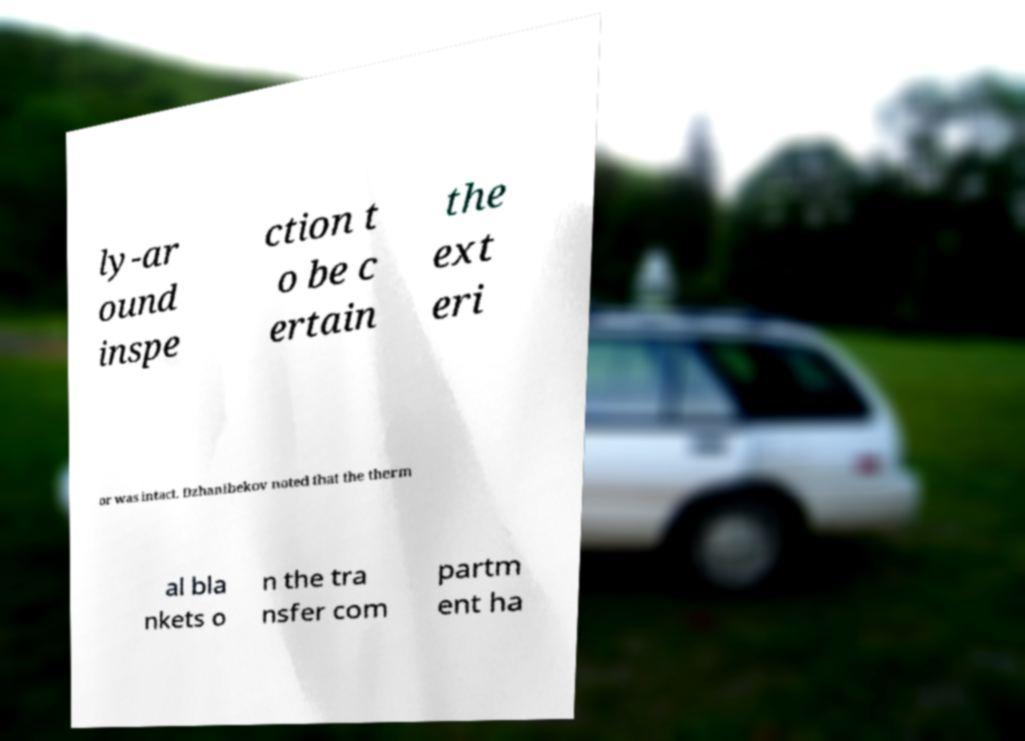Could you extract and type out the text from this image? ly-ar ound inspe ction t o be c ertain the ext eri or was intact. Dzhanibekov noted that the therm al bla nkets o n the tra nsfer com partm ent ha 